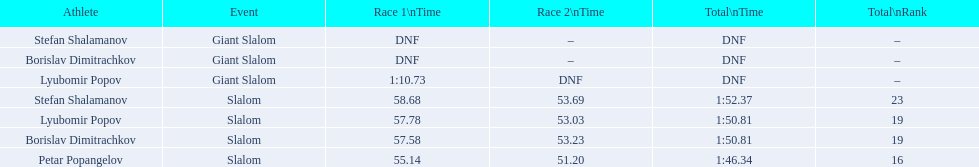Who was the other athlete who tied in rank with lyubomir popov? Borislav Dimitrachkov. Could you parse the entire table? {'header': ['Athlete', 'Event', 'Race 1\\nTime', 'Race 2\\nTime', 'Total\\nTime', 'Total\\nRank'], 'rows': [['Stefan Shalamanov', 'Giant Slalom', 'DNF', '–', 'DNF', '–'], ['Borislav Dimitrachkov', 'Giant Slalom', 'DNF', '–', 'DNF', '–'], ['Lyubomir Popov', 'Giant Slalom', '1:10.73', 'DNF', 'DNF', '–'], ['Stefan Shalamanov', 'Slalom', '58.68', '53.69', '1:52.37', '23'], ['Lyubomir Popov', 'Slalom', '57.78', '53.03', '1:50.81', '19'], ['Borislav Dimitrachkov', 'Slalom', '57.58', '53.23', '1:50.81', '19'], ['Petar Popangelov', 'Slalom', '55.14', '51.20', '1:46.34', '16']]} 